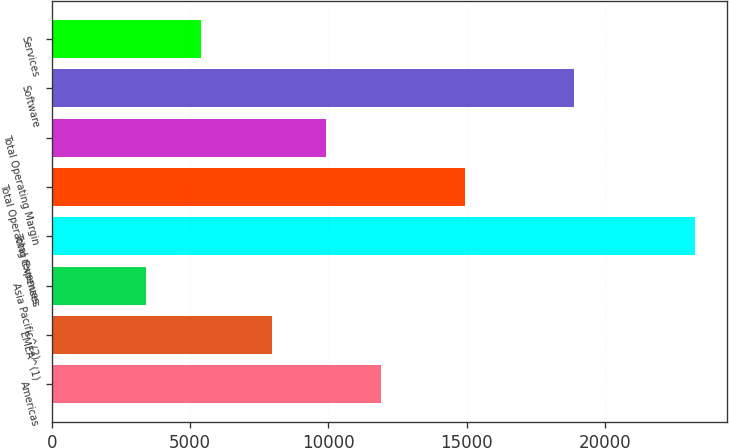<chart> <loc_0><loc_0><loc_500><loc_500><bar_chart><fcel>Americas<fcel>EMEA^(1)<fcel>Asia Pacific^(2)<fcel>Total revenues<fcel>Total Operating Expenses<fcel>Total Operating Margin<fcel>Software<fcel>Services<nl><fcel>11917.6<fcel>7948<fcel>3404<fcel>23252<fcel>14931<fcel>9932.8<fcel>18877<fcel>5388.8<nl></chart> 